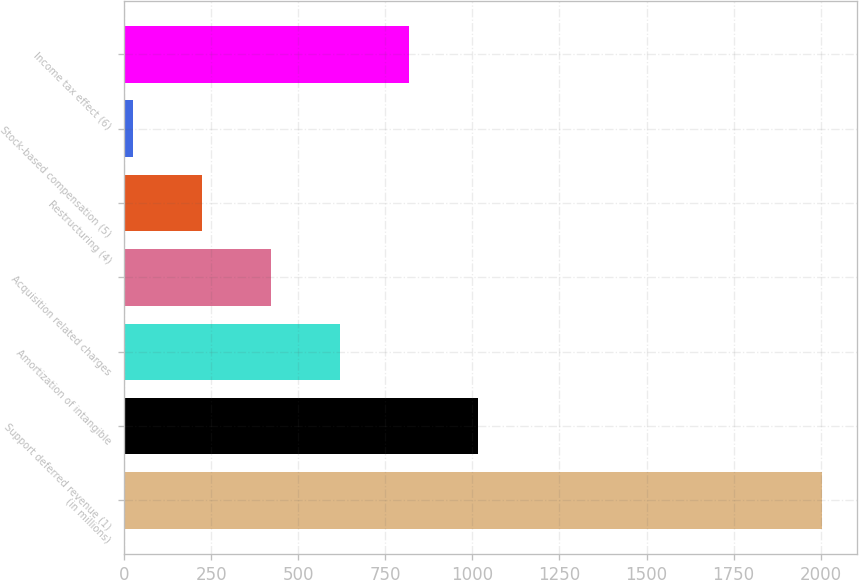Convert chart. <chart><loc_0><loc_0><loc_500><loc_500><bar_chart><fcel>(in millions)<fcel>Support deferred revenue (1)<fcel>Amortization of intangible<fcel>Acquisition related charges<fcel>Restructuring (4)<fcel>Stock-based compensation (5)<fcel>Income tax effect (6)<nl><fcel>2005<fcel>1015<fcel>619<fcel>421<fcel>223<fcel>25<fcel>817<nl></chart> 